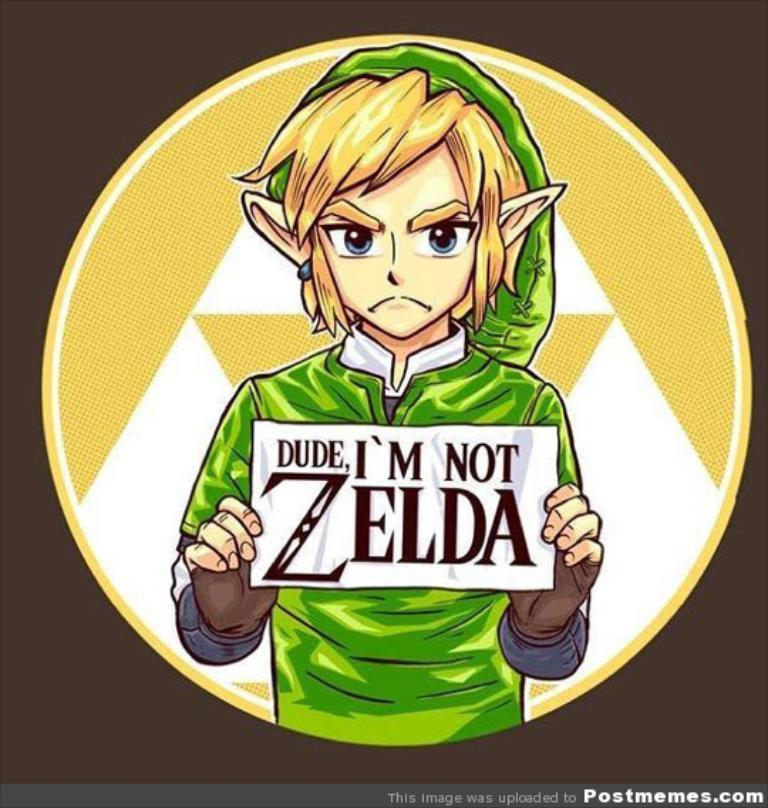Provide a one-sentence caption for the provided image. Link holds a sign that reads Dude, I'm not Zelda. 